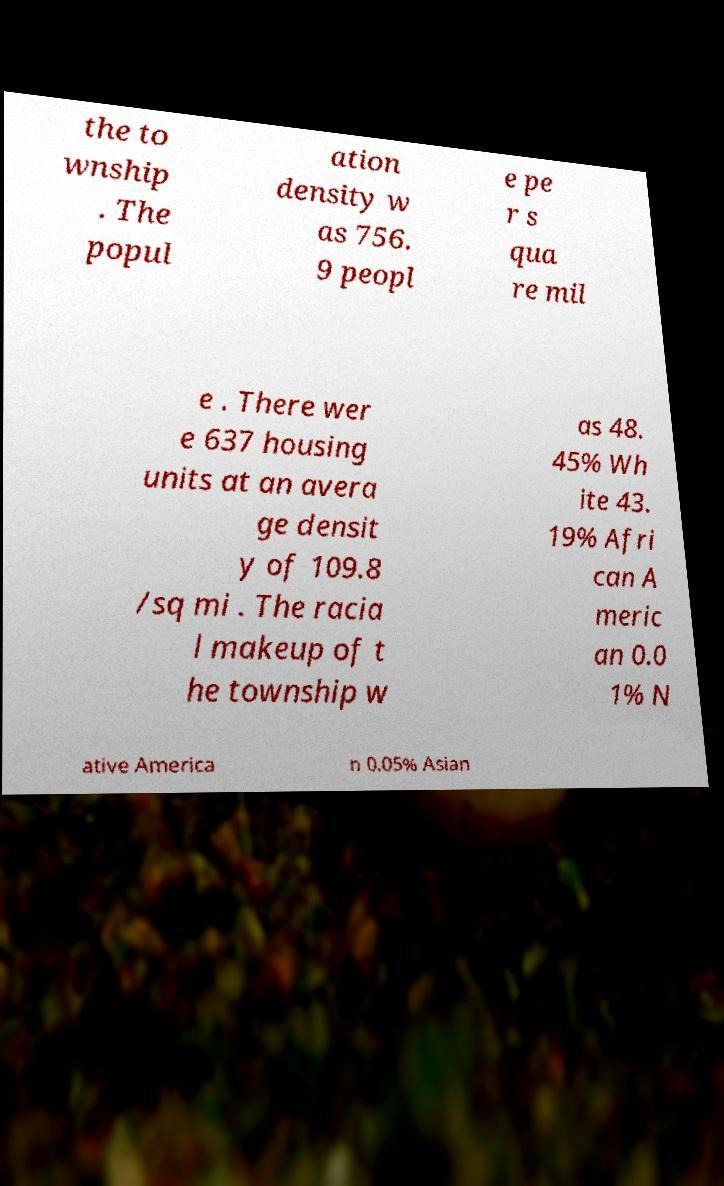Can you accurately transcribe the text from the provided image for me? the to wnship . The popul ation density w as 756. 9 peopl e pe r s qua re mil e . There wer e 637 housing units at an avera ge densit y of 109.8 /sq mi . The racia l makeup of t he township w as 48. 45% Wh ite 43. 19% Afri can A meric an 0.0 1% N ative America n 0.05% Asian 